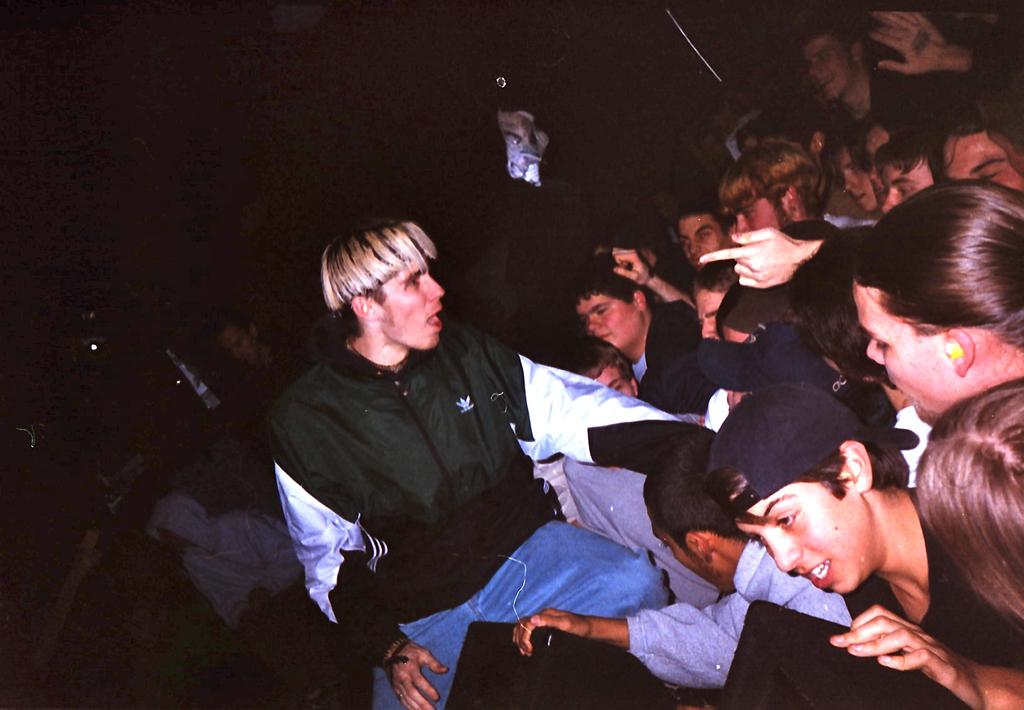How many people are in the image? There is a group of persons standing in the image. Can you describe any specific clothing item worn by one of the persons? One person in the group is wearing a cap. What objects are visible in the foreground of the image? There are speakers visible in the foreground of the image. What type of bridge can be seen in the background of the image? There is no bridge visible in the image; it only shows a group of persons and speakers in the foreground. 